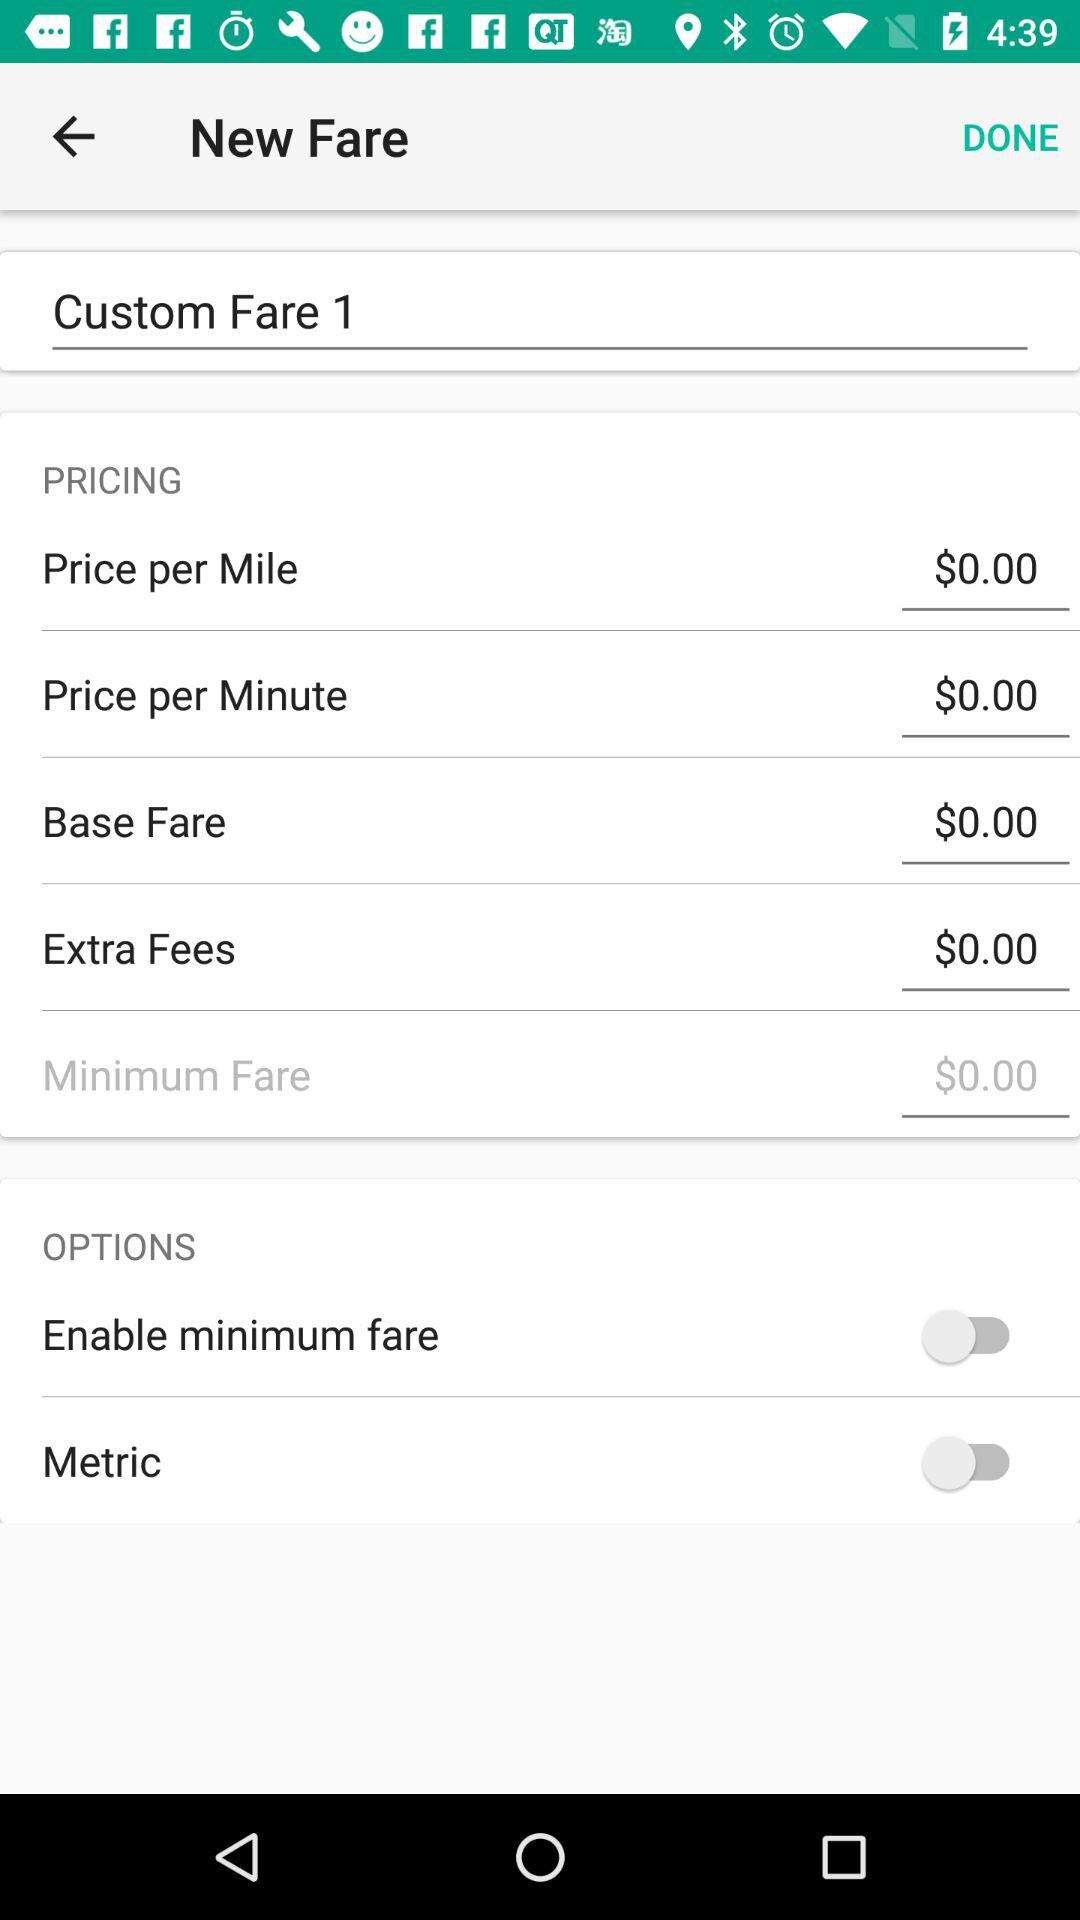What is the status of "Metric"? The status of "Metric" is "off". 